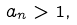<formula> <loc_0><loc_0><loc_500><loc_500>a _ { n } > 1 ,</formula> 